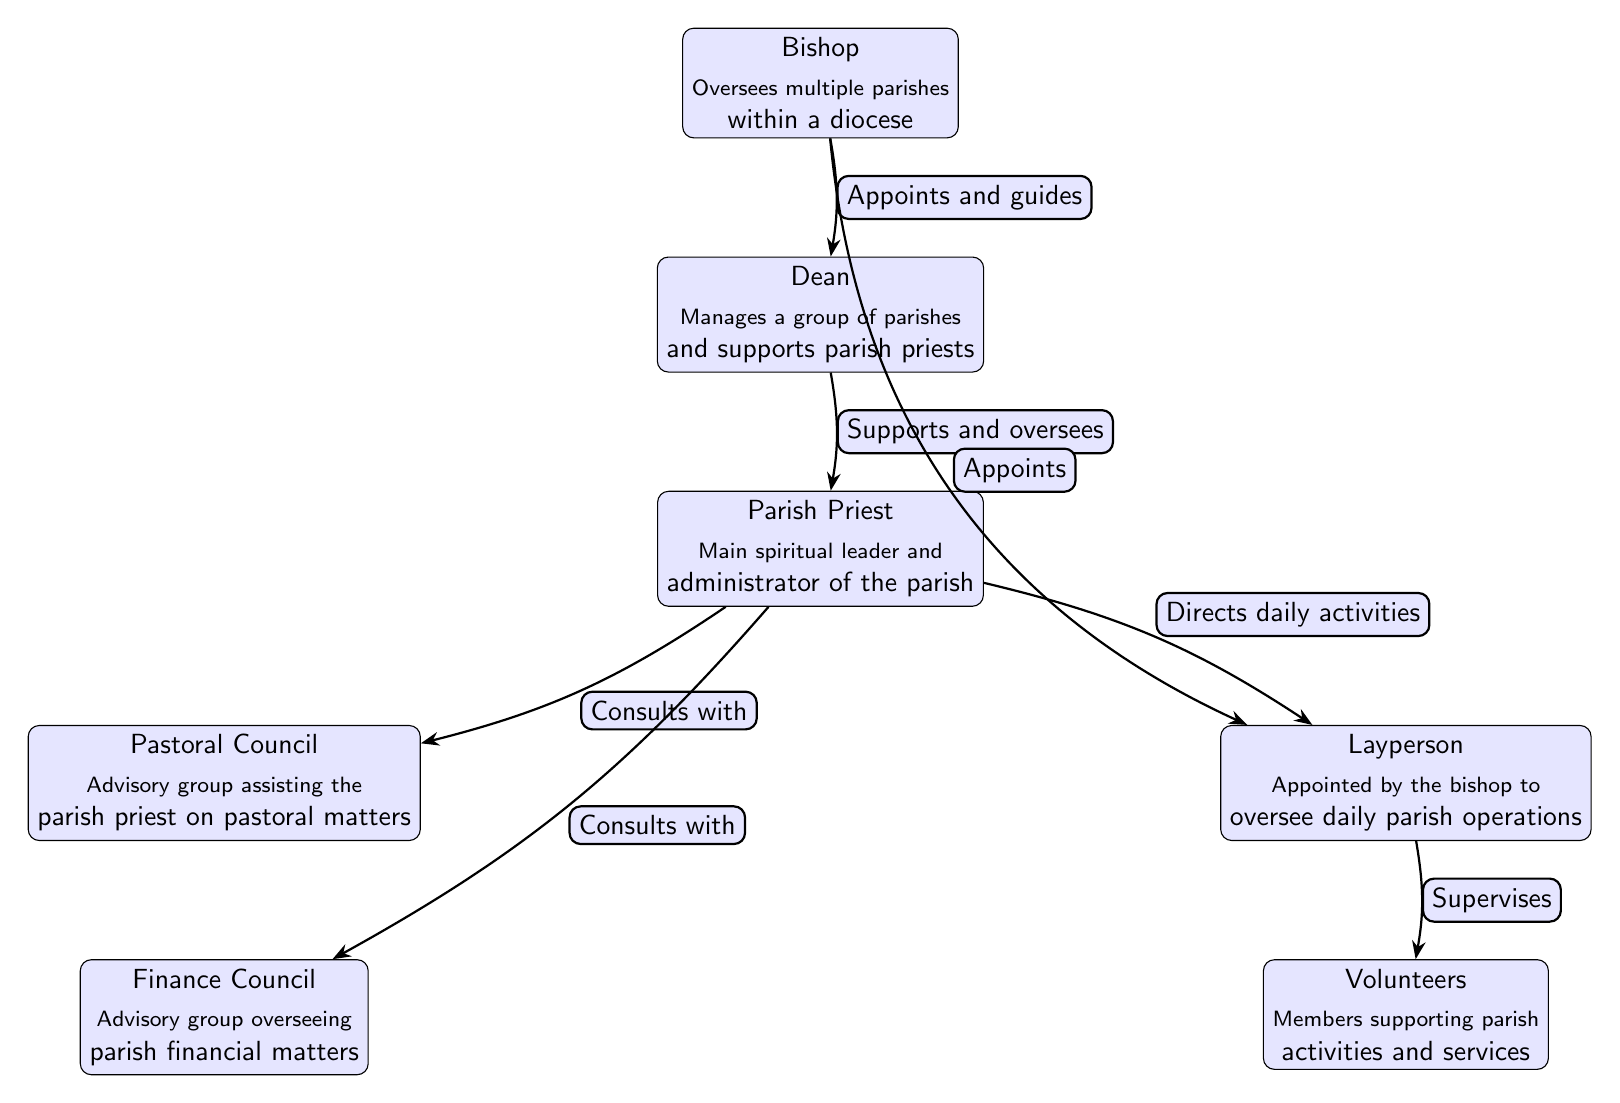What position oversees multiple parishes within a diocese? The diagram indicates that the Bishop is the position responsible for overseeing multiple parishes within a diocese. This information is directly stated in the Bishop's node.
Answer: Bishop What is the role of the Parish Priest? According to the diagram, the Parish Priest acts as the main spiritual leader and administrator of the parish. This description is found within the Parish Priest’s node.
Answer: Main spiritual leader and administrator of the parish How many advisory groups assist the Parish Priest? The diagram shows two advisory groups that assist the Parish Priest: the Pastoral Council and the Finance Council. By counting the nodes directly connected to the Parish Priest labeled as advisory groups, we confirm two.
Answer: 2 Who does the Layperson supervise? The diagram indicates that the Layperson supervises Volunteers. This is shown on the edge connected from Layperson to Volunteers that states "Supervises."
Answer: Volunteers What relationship does the Dean have with the Parish Priest? The edge between the Dean and the Parish Priest states that the Dean "Supports and oversees" the Parish Priest. This information can be found along the corresponding edge in the diagram.
Answer: Supports and oversees What role does the Pastoral Council have in relation to the Parish Priest? The diagram shows that the Pastoral Council "Consults with" the Parish Priest. This relationship is explicitly labeled in the diagram on the edge from Parish Priest to Pastoral Council.
Answer: Consults with What is the Layperson's appointment authority? The diagram specifies that the Layperson is "Appointed by the bishop," indicating that the Layperson’s authority to serve in their role comes from the bishop.
Answer: Appointed by the bishop Which council oversees parish financial matters? The diagram clearly denotes that the Finance Council is the group overseeing parish financial matters, as mentioned in the Finance Council's node.
Answer: Finance Council 